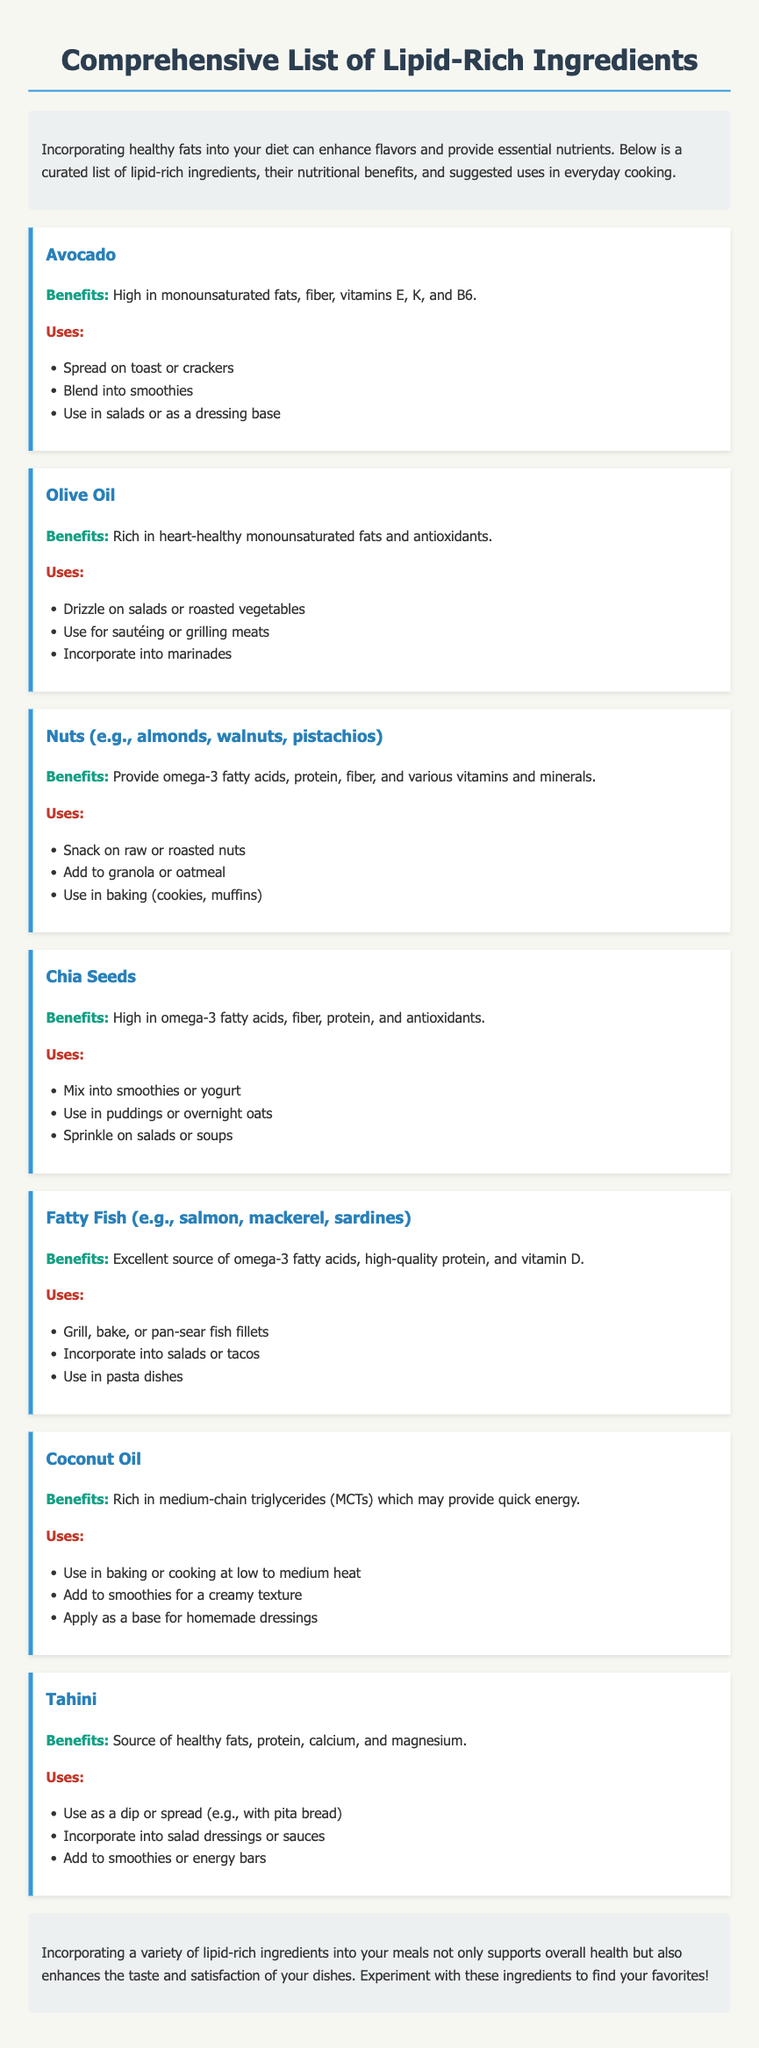What are the main benefits of avocado? The benefits of avocado include high monounsaturated fats, fiber, vitamins E, K, and B6.
Answer: High in monounsaturated fats, fiber, vitamins E, K, and B6 What is a suggested use for olive oil? One suggested use for olive oil is to drizzle on salads or roasted vegetables.
Answer: Drizzle on salads or roasted vegetables Which ingredient provides omega-3 fatty acids, protein, and fiber? Nuts provide omega-3 fatty acids, protein, fiber, and various vitamins and minerals.
Answer: Nuts (e.g., almonds, walnuts, pistachios) How can chia seeds be used in cooking? Chia seeds can be mixed into smoothies or yogurt.
Answer: Mix into smoothies or yogurt What type of fish is recommended for omega-3 fatty acids? Fatty fish such as salmon, mackerel, and sardines are recommended.
Answer: Fatty Fish (e.g., salmon, mackerel, sardines) What is a unique feature of coconut oil? Coconut oil is rich in medium-chain triglycerides (MCTs).
Answer: Rich in medium-chain triglycerides (MCTs) How can tahini be incorporated into meals? Tahini can be added to smoothies or energy bars.
Answer: Add to smoothies or energy bars What do lipid-rich ingredients enhance in meals? Lipid-rich ingredients enhance the taste and satisfaction of dishes.
Answer: Taste and satisfaction 